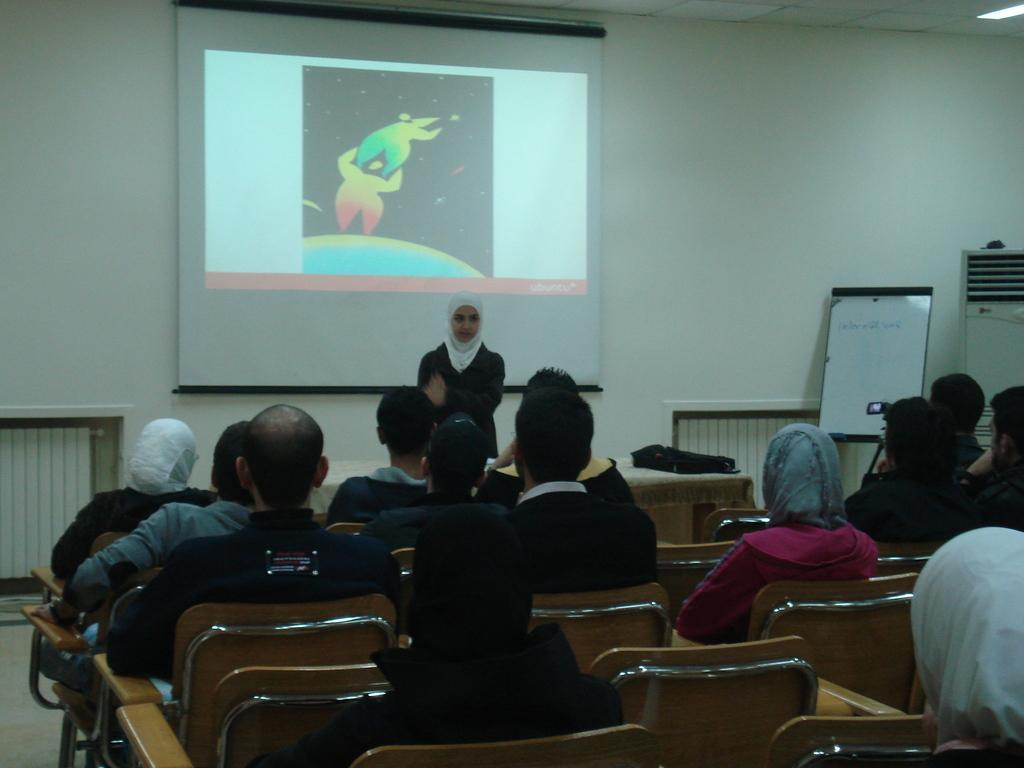Describe this image in one or two sentences. In this image I can see number of people are sitting on chairs and also I can see a person is standing. In the background I can see a projector's screen. 